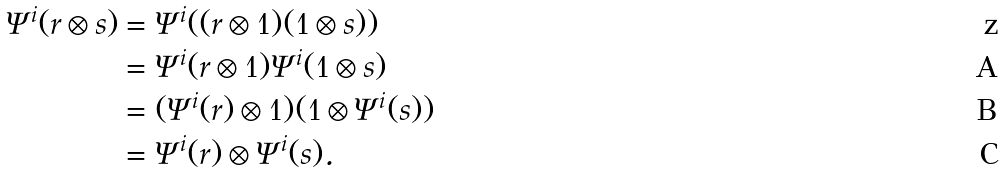<formula> <loc_0><loc_0><loc_500><loc_500>\Psi ^ { i } ( r \otimes s ) & = \Psi ^ { i } ( ( r \otimes 1 ) ( 1 \otimes s ) ) \\ & = \Psi ^ { i } ( r \otimes 1 ) \Psi ^ { i } ( 1 \otimes s ) \\ & = ( \Psi ^ { i } ( r ) \otimes 1 ) ( 1 \otimes \Psi ^ { i } ( s ) ) \\ & = \Psi ^ { i } ( r ) \otimes \Psi ^ { i } ( s ) .</formula> 